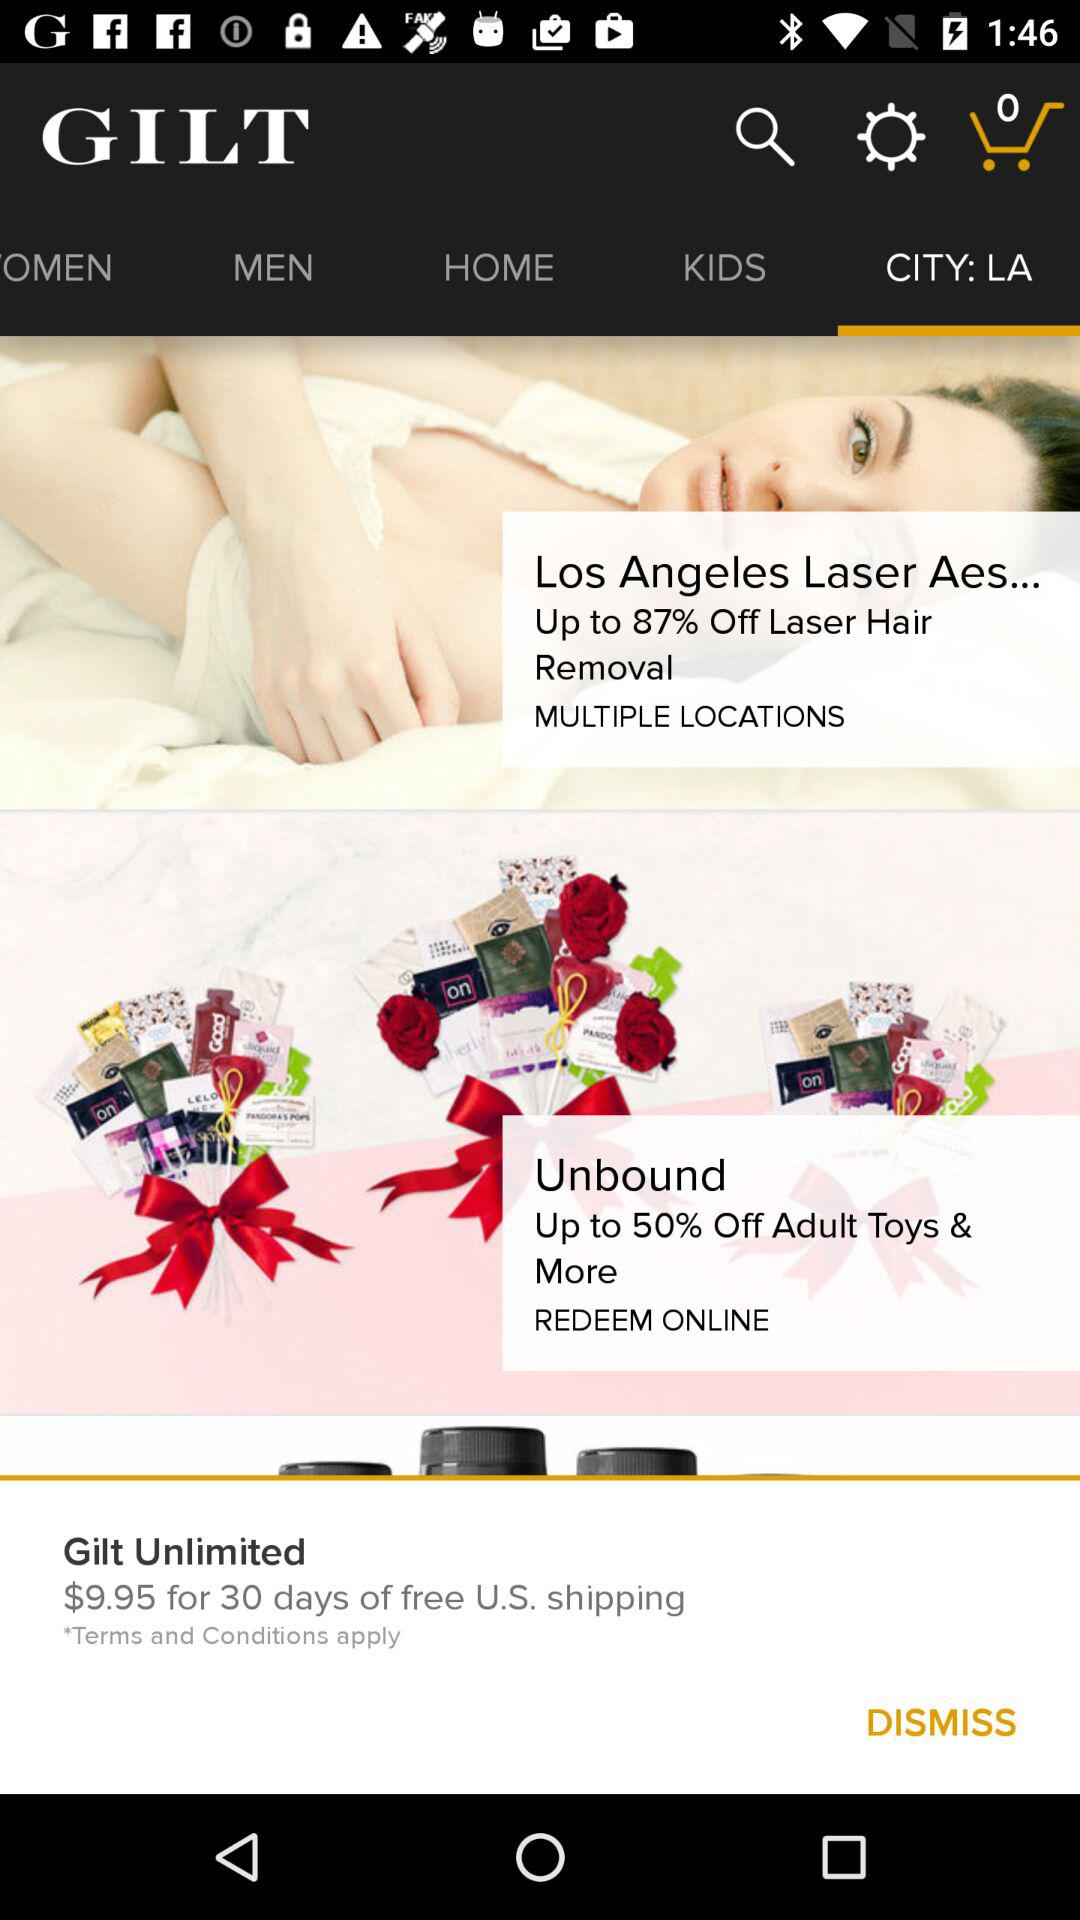What is the discount percentage at "Los Angeles Laser" for hair removal? The discount percentage is up to 87%. 